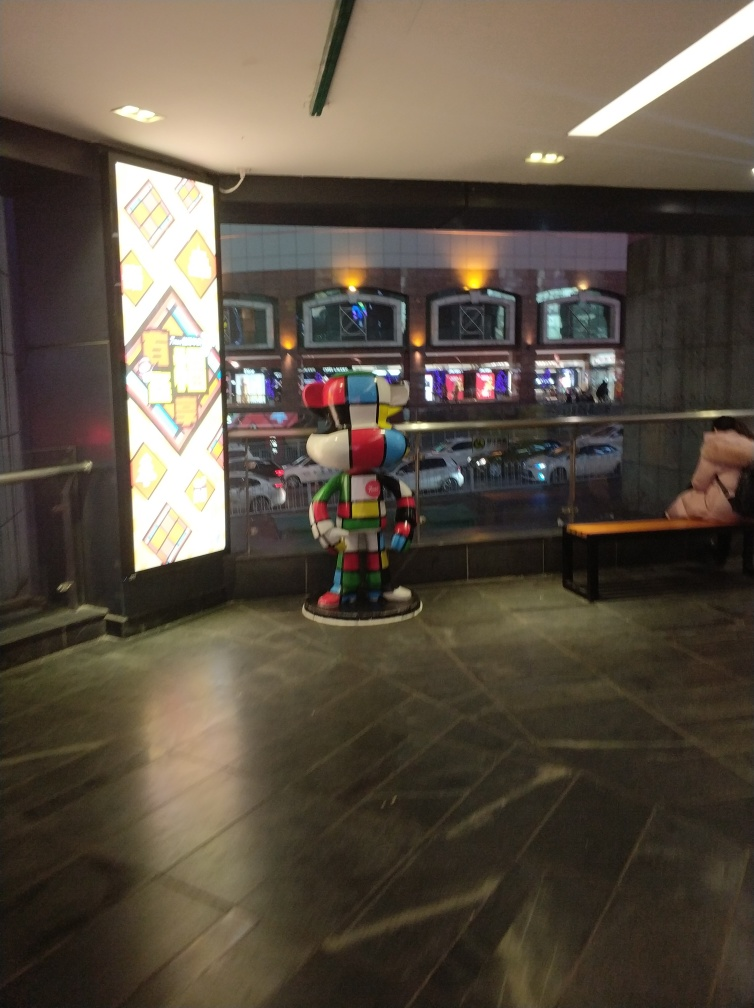Describe the overall atmosphere of the location shown in the image. The image captures an indoor setting that appears to be public, like a lobby or an arcade. The light from the artwork and reflections from the floor contribute to a slightly modern and artistic ambiance. There's a sense of quietness due to the absence of crowd and activity, marked by a single person sitting on a bench at the back. 